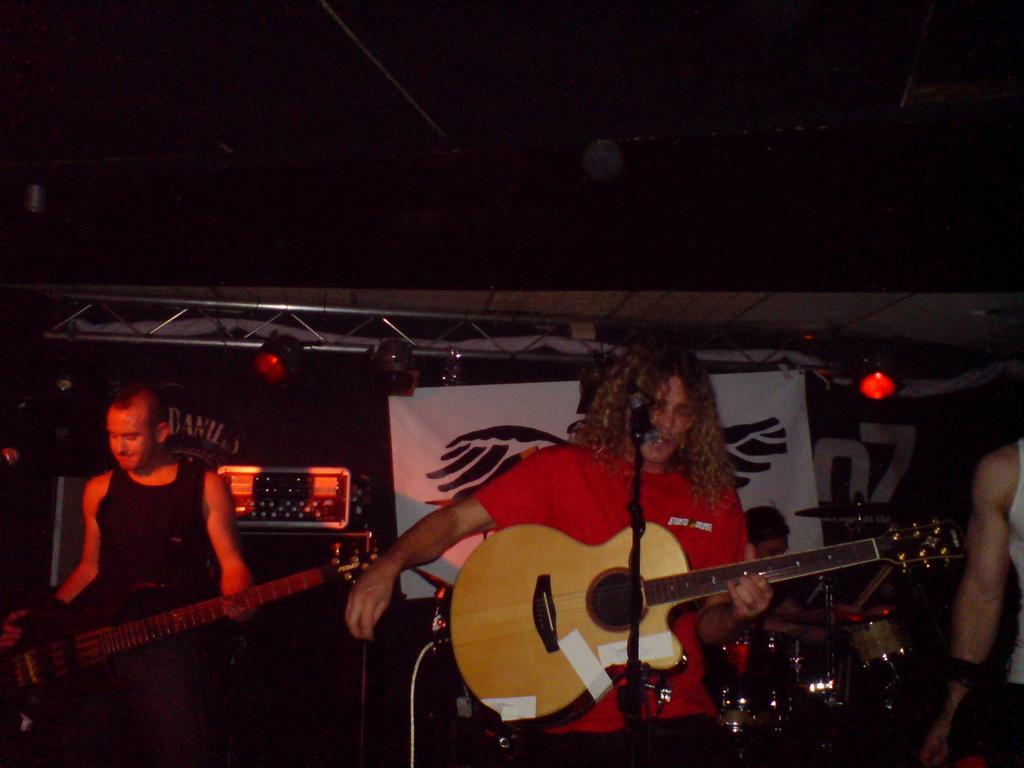How would you summarize this image in a sentence or two? This image is taken in a concert. There are four people on the stage. In the left side of the image a man is standing holding a guitar in his hands. In the right side of the image there is a person standing. In the middle of the image there are two persons one is holding a guitar in his hands and playing the music and the other is siting and playing the music on drums. In the background there is a banner and there are lights. 